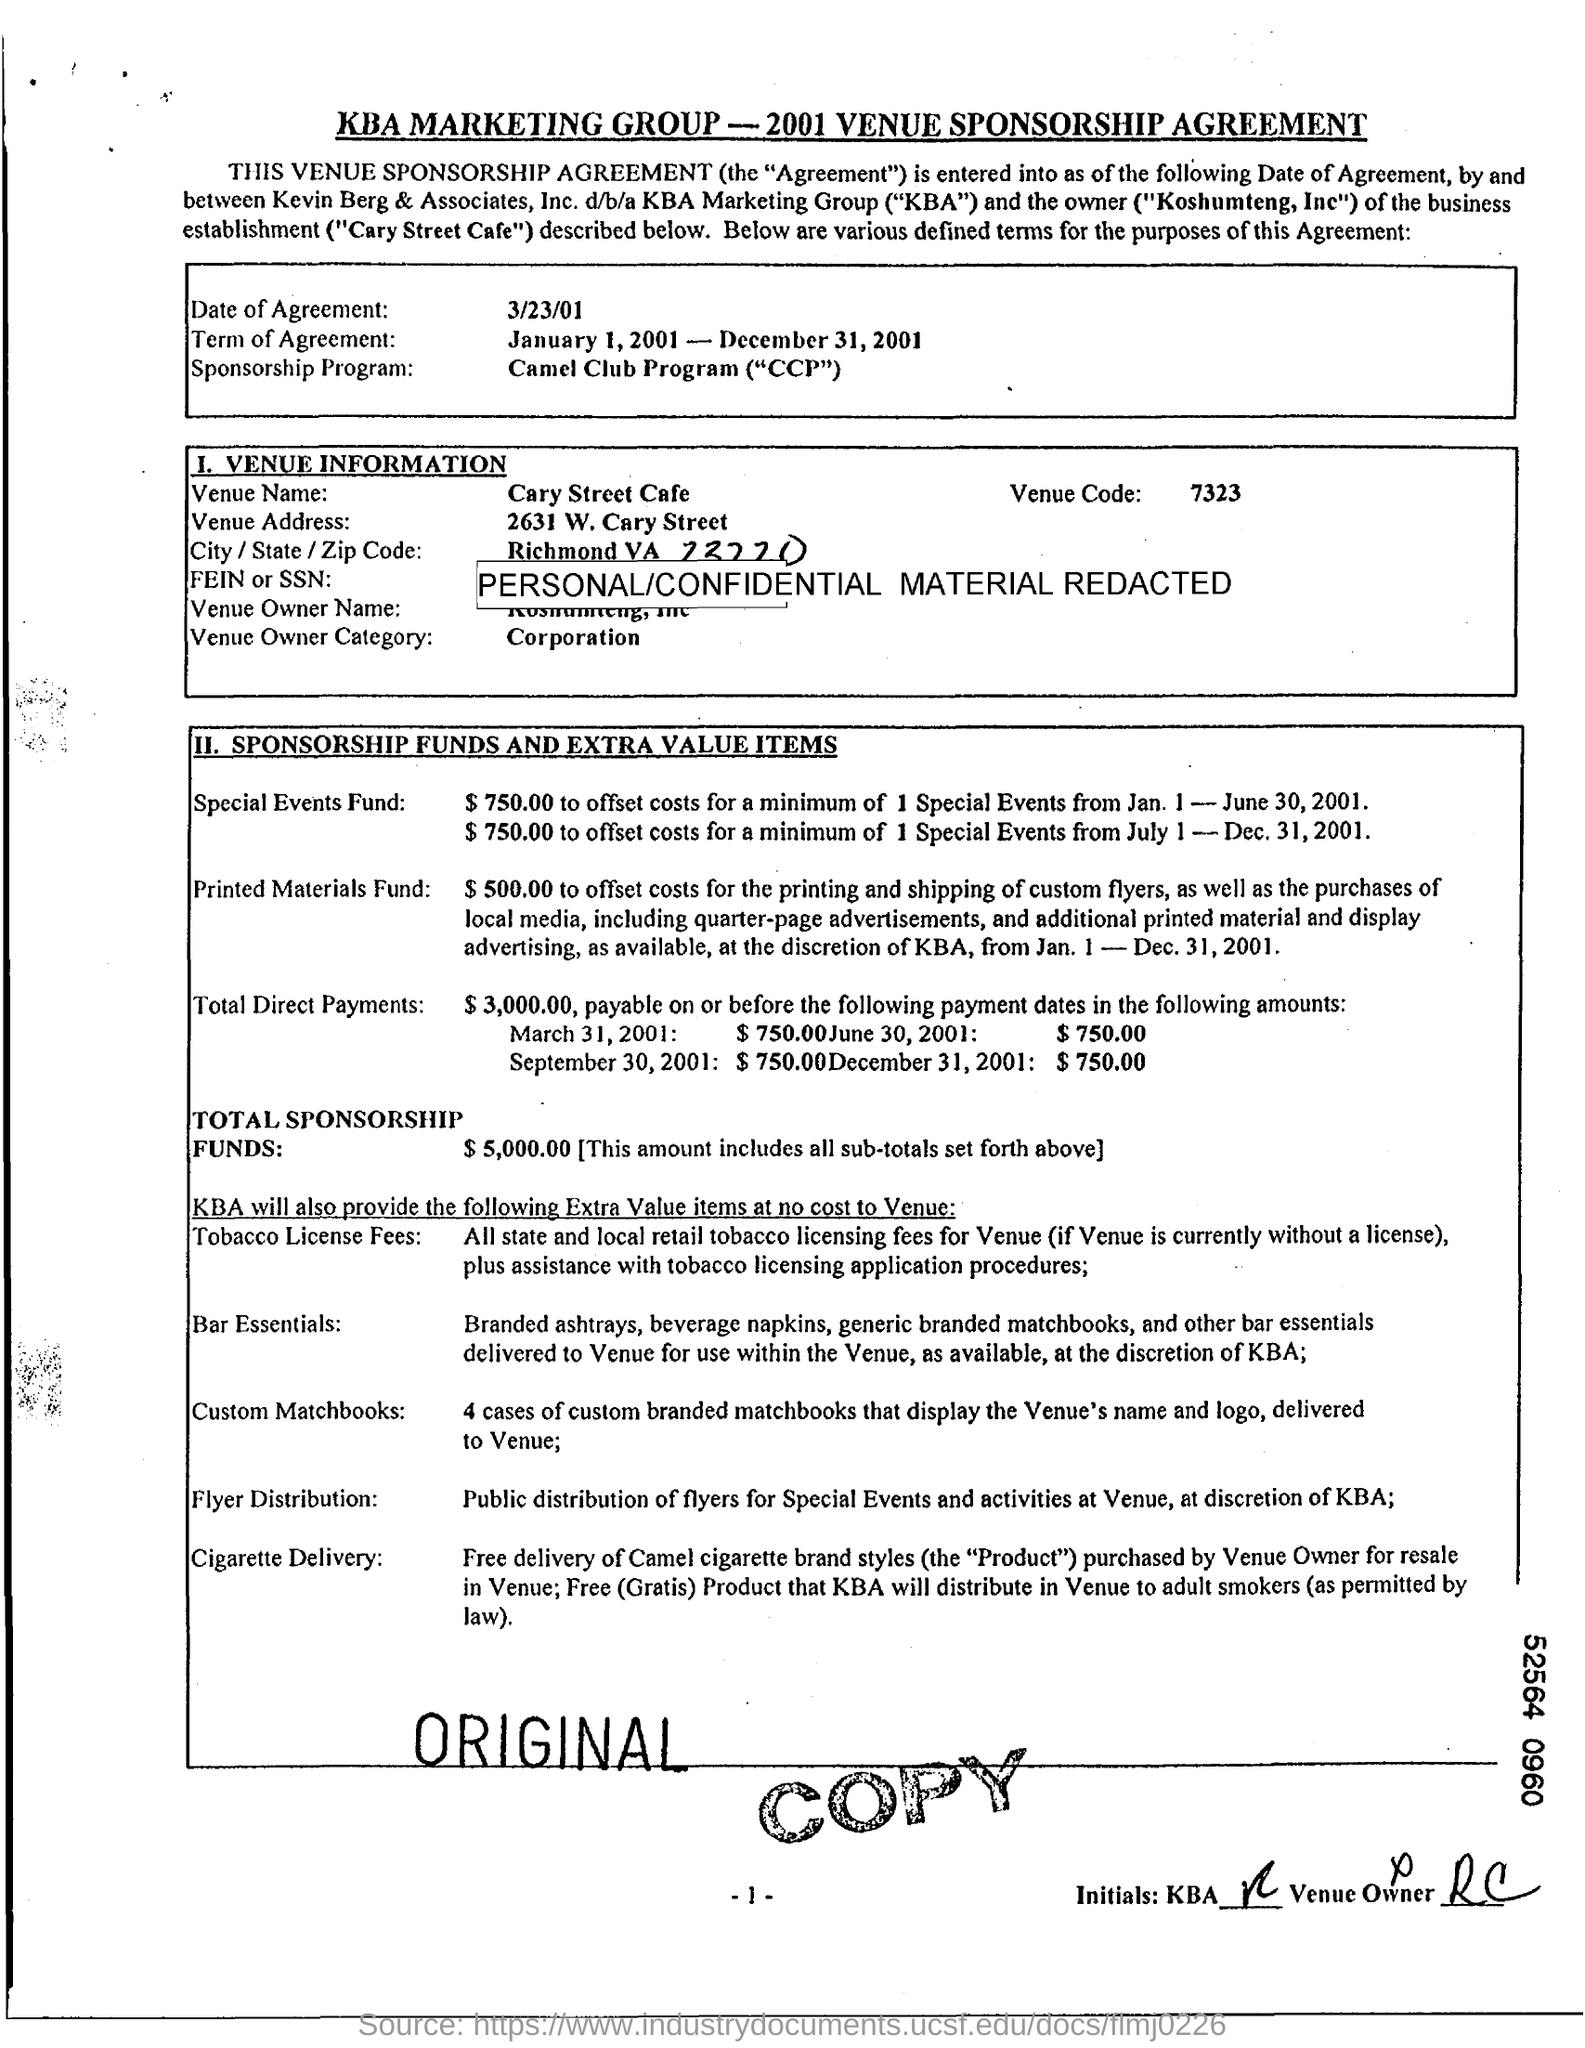Specify some key components in this picture. The Venue Code is a set of guidelines and rules governing the use of venues, such as stadiums and arenas, for events such as concerts and sports games. What is the date of agreement? March 23, 2001. The agreement term is from January 1, 2001 to December 31, 2001. 